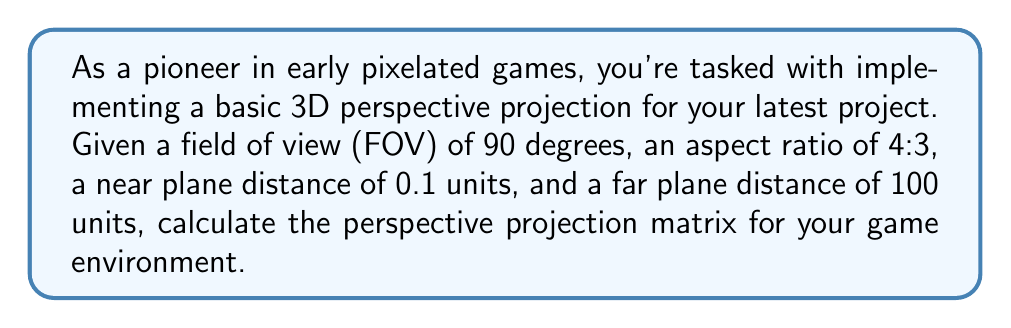Show me your answer to this math problem. To calculate the perspective projection matrix, we'll follow these steps:

1. Convert the FOV from degrees to radians:
   $$ \text{FOV}_\text{rad} = 90^\circ \cdot \frac{\pi}{180^\circ} = \frac{\pi}{2} $$

2. Calculate the cotangent of half the FOV:
   $$ \cot(\frac{\text{FOV}}{2}) = \cot(\frac{\pi}{4}) = 1 $$

3. Determine the aspect ratio:
   $$ \text{aspect} = \frac{4}{3} $$

4. Set the near and far plane distances:
   $$ n = 0.1, \quad f = 100 $$

5. Calculate the matrix elements:
   $$ m_{11} = \frac{\cot(\frac{\text{FOV}}{2})}{\text{aspect}} = \frac{1}{\frac{4}{3}} = \frac{3}{4} $$
   $$ m_{22} = \cot(\frac{\text{FOV}}{2}) = 1 $$
   $$ m_{33} = -\frac{f+n}{f-n} = -\frac{100.1}{99.9} \approx -1.002 $$
   $$ m_{34} = -\frac{2fn}{f-n} = -\frac{2 \cdot 100 \cdot 0.1}{99.9} \approx -0.2002 $$
   $$ m_{43} = -1 $$

6. Construct the perspective projection matrix:
   $$ P = \begin{bmatrix}
   \frac{3}{4} & 0 & 0 & 0 \\
   0 & 1 & 0 & 0 \\
   0 & 0 & -1.002 & -0.2002 \\
   0 & 0 & -1 & 0
   \end{bmatrix} $$

This matrix will transform 3D coordinates in camera space to clip space, providing the desired perspective effect for your early 3D game.
Answer: $$ P = \begin{bmatrix}
0.75 & 0 & 0 & 0 \\
0 & 1 & 0 & 0 \\
0 & 0 & -1.002 & -0.2002 \\
0 & 0 & -1 & 0
\end{bmatrix} $$ 